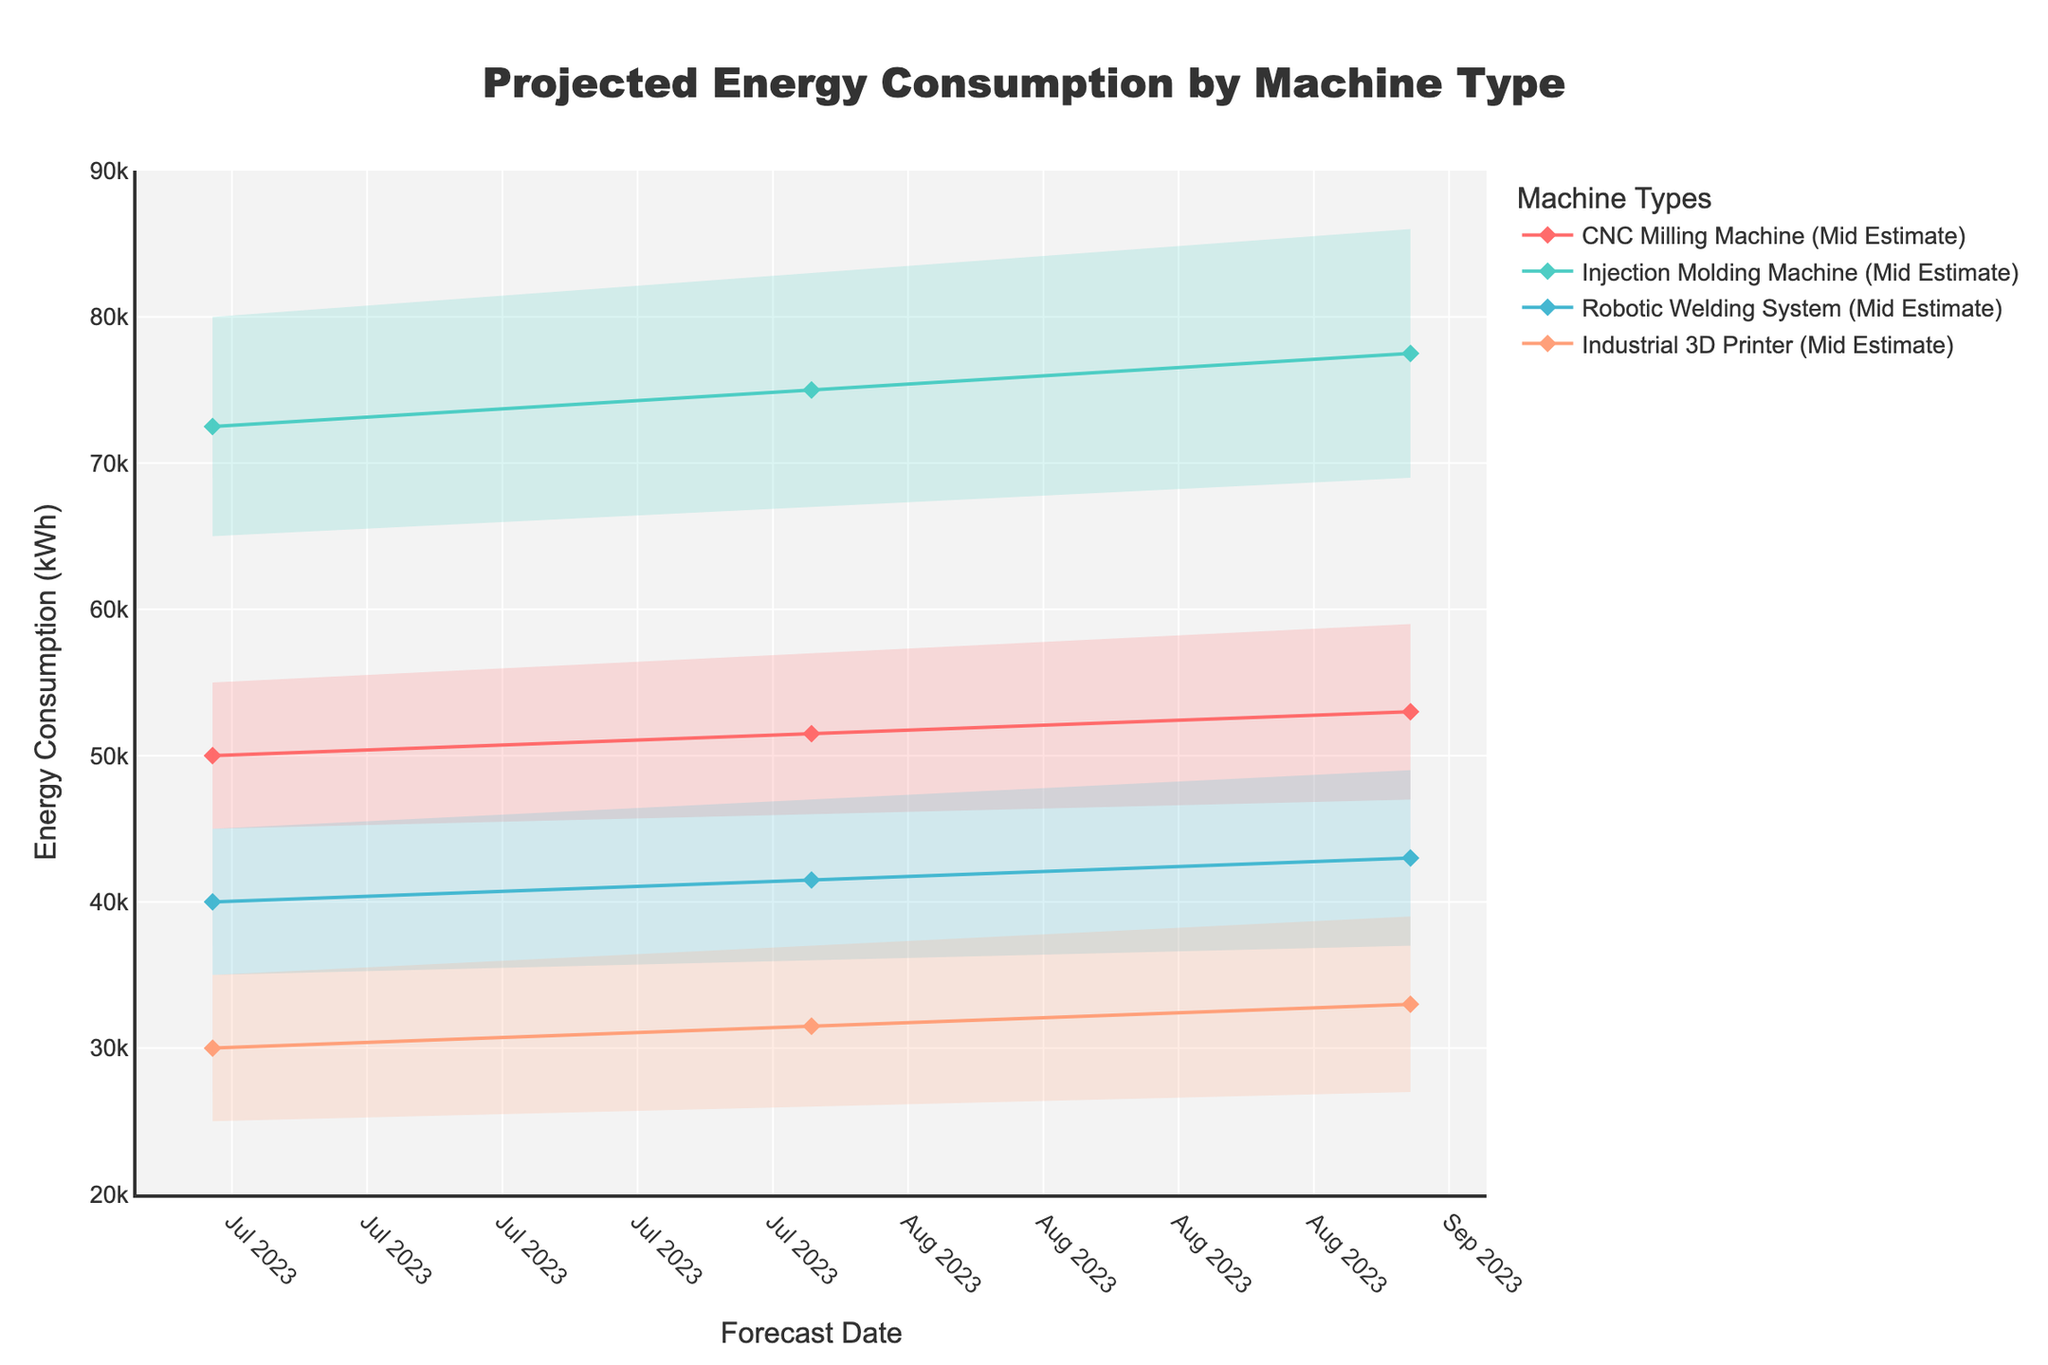What is the title of the figure? The title of the figure is always located at the top center of the plot. By reading the text there, we find the title.
Answer: Projected Energy Consumption by Machine Type How many different machine types are shown in the plot? The legend on the right-hand side of the figure lists all the machine types included in the plot. There are four different machine types listed.
Answer: 4 Which machine type has the highest mid estimate for September 2023? Locate the Mid Estimate line (marked with a diamond) for September 2023 for each machine type, and compare their values. The Injection Molding Machine has the highest mid estimate for September 2023.
Answer: Injection Molding Machine What's the range of the energy consumption forecast for the CNC Milling Machine in August 2023? Look at the fan chart for the CNC Milling Machine for August 2023. The range is from the lowest estimate (46000) to the highest estimate (57000).
Answer: 46000 to 57000 Which machine type shows the smallest increase in mid estimate from July 2023 to September 2023? Calculate the difference in mid estimates between July 2023 and September 2023 for each machine type and compare them. The Industrial 3D Printer shows the smallest increase.
Answer: Industrial 3D Printer What's the average mid estimate for the Robotic Welding System across the three months shown? Sum the mid estimates for the Robotic Welding System for July, August, and September 2023, then divide by three. (40000 + 41500 + 43000) / 3 = 41500
Answer: 41500 Is the high estimate for the Injection Molding Machine higher in August or September 2023? Compare the high estimates for the Injection Molding Machine in August (83000) and September (86000). The September estimate is higher.
Answer: September How does the mid estimate of the Industrial 3D Printer in July 2023 compare to the low estimate of the CNC Milling Machine in the same month? Compare the mid estimate of the Industrial 3D Printer (30000) to the low estimate of the CNC Milling Machine (45000) in July 2023. The mid estimate of the Industrial 3D Printer is lower.
Answer: Lower What is the general trend of the mid estimates for all machine types from July to September 2023? Observe the mid estimate lines for each machine type over the given months. All mid estimate lines show an increasing trend from July to September 2023.
Answer: Increasing 